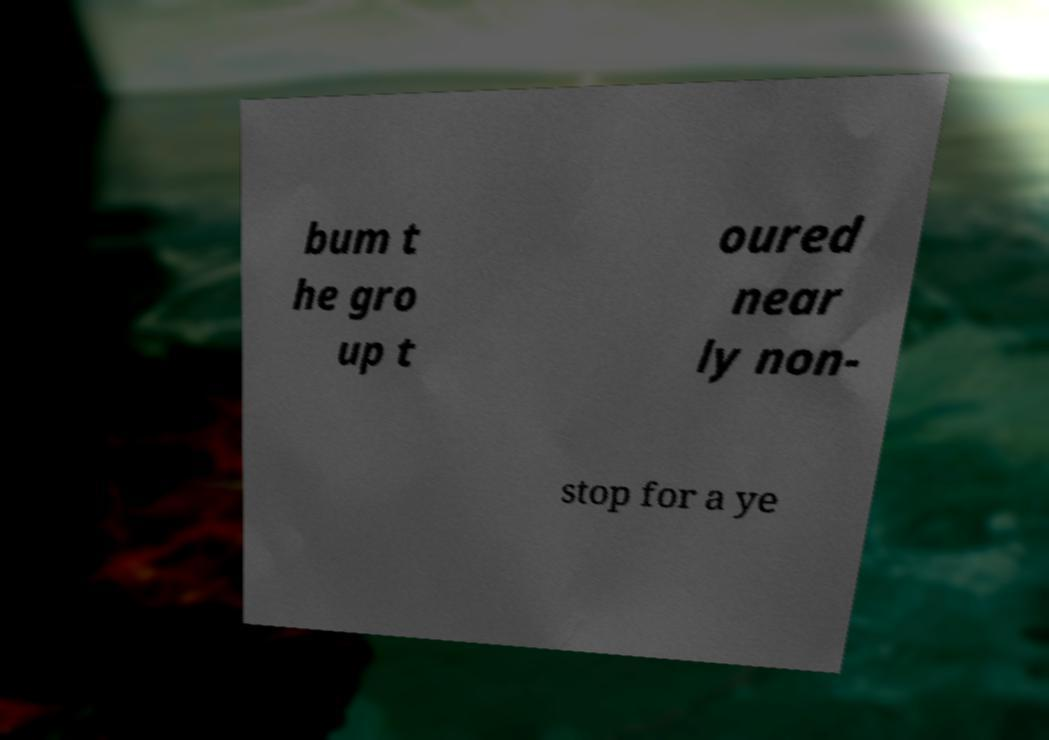There's text embedded in this image that I need extracted. Can you transcribe it verbatim? bum t he gro up t oured near ly non- stop for a ye 